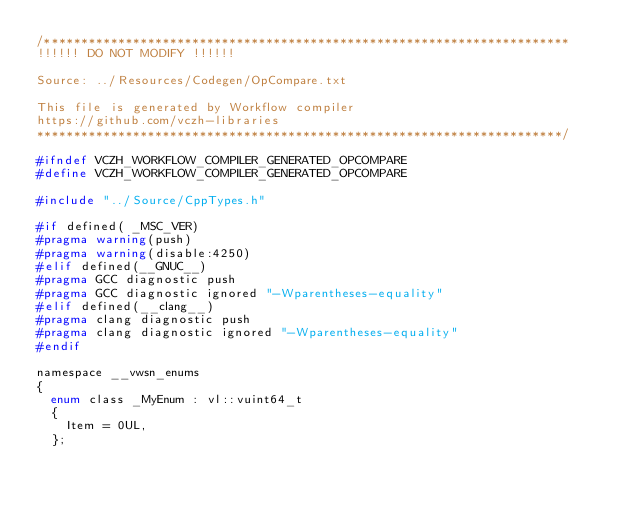Convert code to text. <code><loc_0><loc_0><loc_500><loc_500><_C_>/***********************************************************************
!!!!!! DO NOT MODIFY !!!!!!

Source: ../Resources/Codegen/OpCompare.txt

This file is generated by Workflow compiler
https://github.com/vczh-libraries
***********************************************************************/

#ifndef VCZH_WORKFLOW_COMPILER_GENERATED_OPCOMPARE
#define VCZH_WORKFLOW_COMPILER_GENERATED_OPCOMPARE

#include "../Source/CppTypes.h"

#if defined( _MSC_VER)
#pragma warning(push)
#pragma warning(disable:4250)
#elif defined(__GNUC__)
#pragma GCC diagnostic push
#pragma GCC diagnostic ignored "-Wparentheses-equality"
#elif defined(__clang__)
#pragma clang diagnostic push
#pragma clang diagnostic ignored "-Wparentheses-equality"
#endif

namespace __vwsn_enums
{
	enum class _MyEnum : vl::vuint64_t
	{
		Item = 0UL,
	};</code> 